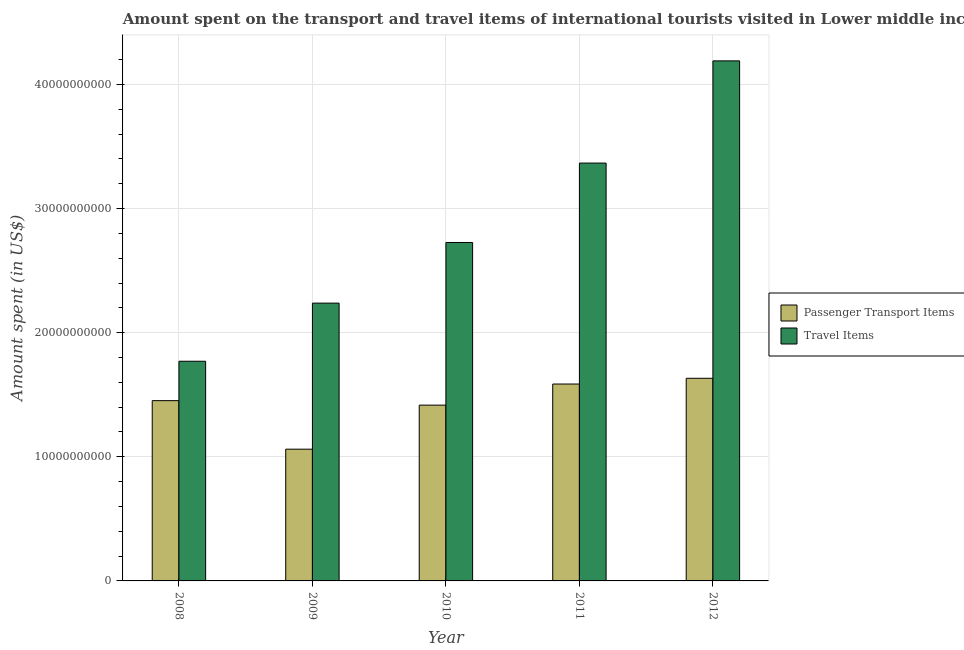How many groups of bars are there?
Keep it short and to the point. 5. Are the number of bars per tick equal to the number of legend labels?
Ensure brevity in your answer.  Yes. How many bars are there on the 4th tick from the left?
Offer a very short reply. 2. What is the label of the 5th group of bars from the left?
Ensure brevity in your answer.  2012. In how many cases, is the number of bars for a given year not equal to the number of legend labels?
Your answer should be compact. 0. What is the amount spent in travel items in 2010?
Offer a very short reply. 2.73e+1. Across all years, what is the maximum amount spent in travel items?
Your answer should be compact. 4.19e+1. Across all years, what is the minimum amount spent in travel items?
Provide a succinct answer. 1.77e+1. In which year was the amount spent in travel items maximum?
Provide a short and direct response. 2012. What is the total amount spent on passenger transport items in the graph?
Your answer should be compact. 7.15e+1. What is the difference between the amount spent on passenger transport items in 2008 and that in 2010?
Make the answer very short. 3.61e+08. What is the difference between the amount spent in travel items in 2012 and the amount spent on passenger transport items in 2009?
Provide a short and direct response. 1.95e+1. What is the average amount spent on passenger transport items per year?
Make the answer very short. 1.43e+1. In how many years, is the amount spent on passenger transport items greater than 4000000000 US$?
Provide a succinct answer. 5. What is the ratio of the amount spent in travel items in 2009 to that in 2011?
Your answer should be very brief. 0.66. What is the difference between the highest and the second highest amount spent on passenger transport items?
Make the answer very short. 4.63e+08. What is the difference between the highest and the lowest amount spent in travel items?
Offer a terse response. 2.42e+1. Is the sum of the amount spent in travel items in 2008 and 2011 greater than the maximum amount spent on passenger transport items across all years?
Give a very brief answer. Yes. What does the 2nd bar from the left in 2008 represents?
Give a very brief answer. Travel Items. What does the 1st bar from the right in 2008 represents?
Your answer should be very brief. Travel Items. Are all the bars in the graph horizontal?
Provide a succinct answer. No. How many years are there in the graph?
Make the answer very short. 5. What is the difference between two consecutive major ticks on the Y-axis?
Keep it short and to the point. 1.00e+1. Where does the legend appear in the graph?
Your response must be concise. Center right. How many legend labels are there?
Your answer should be compact. 2. What is the title of the graph?
Keep it short and to the point. Amount spent on the transport and travel items of international tourists visited in Lower middle income. Does "Urban agglomerations" appear as one of the legend labels in the graph?
Provide a succinct answer. No. What is the label or title of the X-axis?
Provide a short and direct response. Year. What is the label or title of the Y-axis?
Make the answer very short. Amount spent (in US$). What is the Amount spent (in US$) in Passenger Transport Items in 2008?
Your answer should be very brief. 1.45e+1. What is the Amount spent (in US$) of Travel Items in 2008?
Keep it short and to the point. 1.77e+1. What is the Amount spent (in US$) in Passenger Transport Items in 2009?
Ensure brevity in your answer.  1.06e+1. What is the Amount spent (in US$) in Travel Items in 2009?
Ensure brevity in your answer.  2.24e+1. What is the Amount spent (in US$) of Passenger Transport Items in 2010?
Keep it short and to the point. 1.42e+1. What is the Amount spent (in US$) in Travel Items in 2010?
Your response must be concise. 2.73e+1. What is the Amount spent (in US$) in Passenger Transport Items in 2011?
Make the answer very short. 1.59e+1. What is the Amount spent (in US$) in Travel Items in 2011?
Make the answer very short. 3.37e+1. What is the Amount spent (in US$) of Passenger Transport Items in 2012?
Ensure brevity in your answer.  1.63e+1. What is the Amount spent (in US$) in Travel Items in 2012?
Offer a terse response. 4.19e+1. Across all years, what is the maximum Amount spent (in US$) in Passenger Transport Items?
Keep it short and to the point. 1.63e+1. Across all years, what is the maximum Amount spent (in US$) of Travel Items?
Provide a short and direct response. 4.19e+1. Across all years, what is the minimum Amount spent (in US$) in Passenger Transport Items?
Provide a short and direct response. 1.06e+1. Across all years, what is the minimum Amount spent (in US$) in Travel Items?
Your answer should be compact. 1.77e+1. What is the total Amount spent (in US$) in Passenger Transport Items in the graph?
Provide a short and direct response. 7.15e+1. What is the total Amount spent (in US$) in Travel Items in the graph?
Offer a very short reply. 1.43e+11. What is the difference between the Amount spent (in US$) of Passenger Transport Items in 2008 and that in 2009?
Your answer should be compact. 3.91e+09. What is the difference between the Amount spent (in US$) in Travel Items in 2008 and that in 2009?
Provide a short and direct response. -4.68e+09. What is the difference between the Amount spent (in US$) of Passenger Transport Items in 2008 and that in 2010?
Offer a very short reply. 3.61e+08. What is the difference between the Amount spent (in US$) of Travel Items in 2008 and that in 2010?
Provide a short and direct response. -9.57e+09. What is the difference between the Amount spent (in US$) of Passenger Transport Items in 2008 and that in 2011?
Your answer should be very brief. -1.34e+09. What is the difference between the Amount spent (in US$) in Travel Items in 2008 and that in 2011?
Provide a succinct answer. -1.60e+1. What is the difference between the Amount spent (in US$) in Passenger Transport Items in 2008 and that in 2012?
Ensure brevity in your answer.  -1.80e+09. What is the difference between the Amount spent (in US$) of Travel Items in 2008 and that in 2012?
Offer a terse response. -2.42e+1. What is the difference between the Amount spent (in US$) in Passenger Transport Items in 2009 and that in 2010?
Offer a very short reply. -3.55e+09. What is the difference between the Amount spent (in US$) of Travel Items in 2009 and that in 2010?
Your response must be concise. -4.88e+09. What is the difference between the Amount spent (in US$) of Passenger Transport Items in 2009 and that in 2011?
Offer a terse response. -5.25e+09. What is the difference between the Amount spent (in US$) in Travel Items in 2009 and that in 2011?
Offer a very short reply. -1.13e+1. What is the difference between the Amount spent (in US$) of Passenger Transport Items in 2009 and that in 2012?
Ensure brevity in your answer.  -5.71e+09. What is the difference between the Amount spent (in US$) of Travel Items in 2009 and that in 2012?
Make the answer very short. -1.95e+1. What is the difference between the Amount spent (in US$) of Passenger Transport Items in 2010 and that in 2011?
Make the answer very short. -1.70e+09. What is the difference between the Amount spent (in US$) of Travel Items in 2010 and that in 2011?
Make the answer very short. -6.40e+09. What is the difference between the Amount spent (in US$) in Passenger Transport Items in 2010 and that in 2012?
Your response must be concise. -2.16e+09. What is the difference between the Amount spent (in US$) of Travel Items in 2010 and that in 2012?
Provide a short and direct response. -1.46e+1. What is the difference between the Amount spent (in US$) in Passenger Transport Items in 2011 and that in 2012?
Give a very brief answer. -4.63e+08. What is the difference between the Amount spent (in US$) in Travel Items in 2011 and that in 2012?
Your response must be concise. -8.23e+09. What is the difference between the Amount spent (in US$) in Passenger Transport Items in 2008 and the Amount spent (in US$) in Travel Items in 2009?
Provide a short and direct response. -7.86e+09. What is the difference between the Amount spent (in US$) in Passenger Transport Items in 2008 and the Amount spent (in US$) in Travel Items in 2010?
Your answer should be very brief. -1.27e+1. What is the difference between the Amount spent (in US$) in Passenger Transport Items in 2008 and the Amount spent (in US$) in Travel Items in 2011?
Your response must be concise. -1.91e+1. What is the difference between the Amount spent (in US$) of Passenger Transport Items in 2008 and the Amount spent (in US$) of Travel Items in 2012?
Your answer should be compact. -2.74e+1. What is the difference between the Amount spent (in US$) of Passenger Transport Items in 2009 and the Amount spent (in US$) of Travel Items in 2010?
Provide a succinct answer. -1.67e+1. What is the difference between the Amount spent (in US$) of Passenger Transport Items in 2009 and the Amount spent (in US$) of Travel Items in 2011?
Your answer should be compact. -2.31e+1. What is the difference between the Amount spent (in US$) in Passenger Transport Items in 2009 and the Amount spent (in US$) in Travel Items in 2012?
Your answer should be very brief. -3.13e+1. What is the difference between the Amount spent (in US$) of Passenger Transport Items in 2010 and the Amount spent (in US$) of Travel Items in 2011?
Ensure brevity in your answer.  -1.95e+1. What is the difference between the Amount spent (in US$) of Passenger Transport Items in 2010 and the Amount spent (in US$) of Travel Items in 2012?
Your response must be concise. -2.77e+1. What is the difference between the Amount spent (in US$) of Passenger Transport Items in 2011 and the Amount spent (in US$) of Travel Items in 2012?
Your answer should be very brief. -2.60e+1. What is the average Amount spent (in US$) of Passenger Transport Items per year?
Ensure brevity in your answer.  1.43e+1. What is the average Amount spent (in US$) of Travel Items per year?
Your answer should be compact. 2.86e+1. In the year 2008, what is the difference between the Amount spent (in US$) in Passenger Transport Items and Amount spent (in US$) in Travel Items?
Keep it short and to the point. -3.17e+09. In the year 2009, what is the difference between the Amount spent (in US$) in Passenger Transport Items and Amount spent (in US$) in Travel Items?
Keep it short and to the point. -1.18e+1. In the year 2010, what is the difference between the Amount spent (in US$) of Passenger Transport Items and Amount spent (in US$) of Travel Items?
Ensure brevity in your answer.  -1.31e+1. In the year 2011, what is the difference between the Amount spent (in US$) of Passenger Transport Items and Amount spent (in US$) of Travel Items?
Offer a very short reply. -1.78e+1. In the year 2012, what is the difference between the Amount spent (in US$) of Passenger Transport Items and Amount spent (in US$) of Travel Items?
Your response must be concise. -2.56e+1. What is the ratio of the Amount spent (in US$) in Passenger Transport Items in 2008 to that in 2009?
Your answer should be very brief. 1.37. What is the ratio of the Amount spent (in US$) of Travel Items in 2008 to that in 2009?
Make the answer very short. 0.79. What is the ratio of the Amount spent (in US$) of Passenger Transport Items in 2008 to that in 2010?
Ensure brevity in your answer.  1.03. What is the ratio of the Amount spent (in US$) of Travel Items in 2008 to that in 2010?
Your answer should be compact. 0.65. What is the ratio of the Amount spent (in US$) in Passenger Transport Items in 2008 to that in 2011?
Make the answer very short. 0.92. What is the ratio of the Amount spent (in US$) of Travel Items in 2008 to that in 2011?
Your answer should be compact. 0.53. What is the ratio of the Amount spent (in US$) of Passenger Transport Items in 2008 to that in 2012?
Your response must be concise. 0.89. What is the ratio of the Amount spent (in US$) in Travel Items in 2008 to that in 2012?
Make the answer very short. 0.42. What is the ratio of the Amount spent (in US$) of Passenger Transport Items in 2009 to that in 2010?
Make the answer very short. 0.75. What is the ratio of the Amount spent (in US$) of Travel Items in 2009 to that in 2010?
Give a very brief answer. 0.82. What is the ratio of the Amount spent (in US$) in Passenger Transport Items in 2009 to that in 2011?
Keep it short and to the point. 0.67. What is the ratio of the Amount spent (in US$) in Travel Items in 2009 to that in 2011?
Make the answer very short. 0.66. What is the ratio of the Amount spent (in US$) of Passenger Transport Items in 2009 to that in 2012?
Offer a terse response. 0.65. What is the ratio of the Amount spent (in US$) in Travel Items in 2009 to that in 2012?
Provide a succinct answer. 0.53. What is the ratio of the Amount spent (in US$) in Passenger Transport Items in 2010 to that in 2011?
Make the answer very short. 0.89. What is the ratio of the Amount spent (in US$) in Travel Items in 2010 to that in 2011?
Your answer should be compact. 0.81. What is the ratio of the Amount spent (in US$) of Passenger Transport Items in 2010 to that in 2012?
Provide a short and direct response. 0.87. What is the ratio of the Amount spent (in US$) in Travel Items in 2010 to that in 2012?
Offer a terse response. 0.65. What is the ratio of the Amount spent (in US$) of Passenger Transport Items in 2011 to that in 2012?
Make the answer very short. 0.97. What is the ratio of the Amount spent (in US$) in Travel Items in 2011 to that in 2012?
Your response must be concise. 0.8. What is the difference between the highest and the second highest Amount spent (in US$) in Passenger Transport Items?
Offer a very short reply. 4.63e+08. What is the difference between the highest and the second highest Amount spent (in US$) of Travel Items?
Give a very brief answer. 8.23e+09. What is the difference between the highest and the lowest Amount spent (in US$) of Passenger Transport Items?
Provide a succinct answer. 5.71e+09. What is the difference between the highest and the lowest Amount spent (in US$) in Travel Items?
Ensure brevity in your answer.  2.42e+1. 